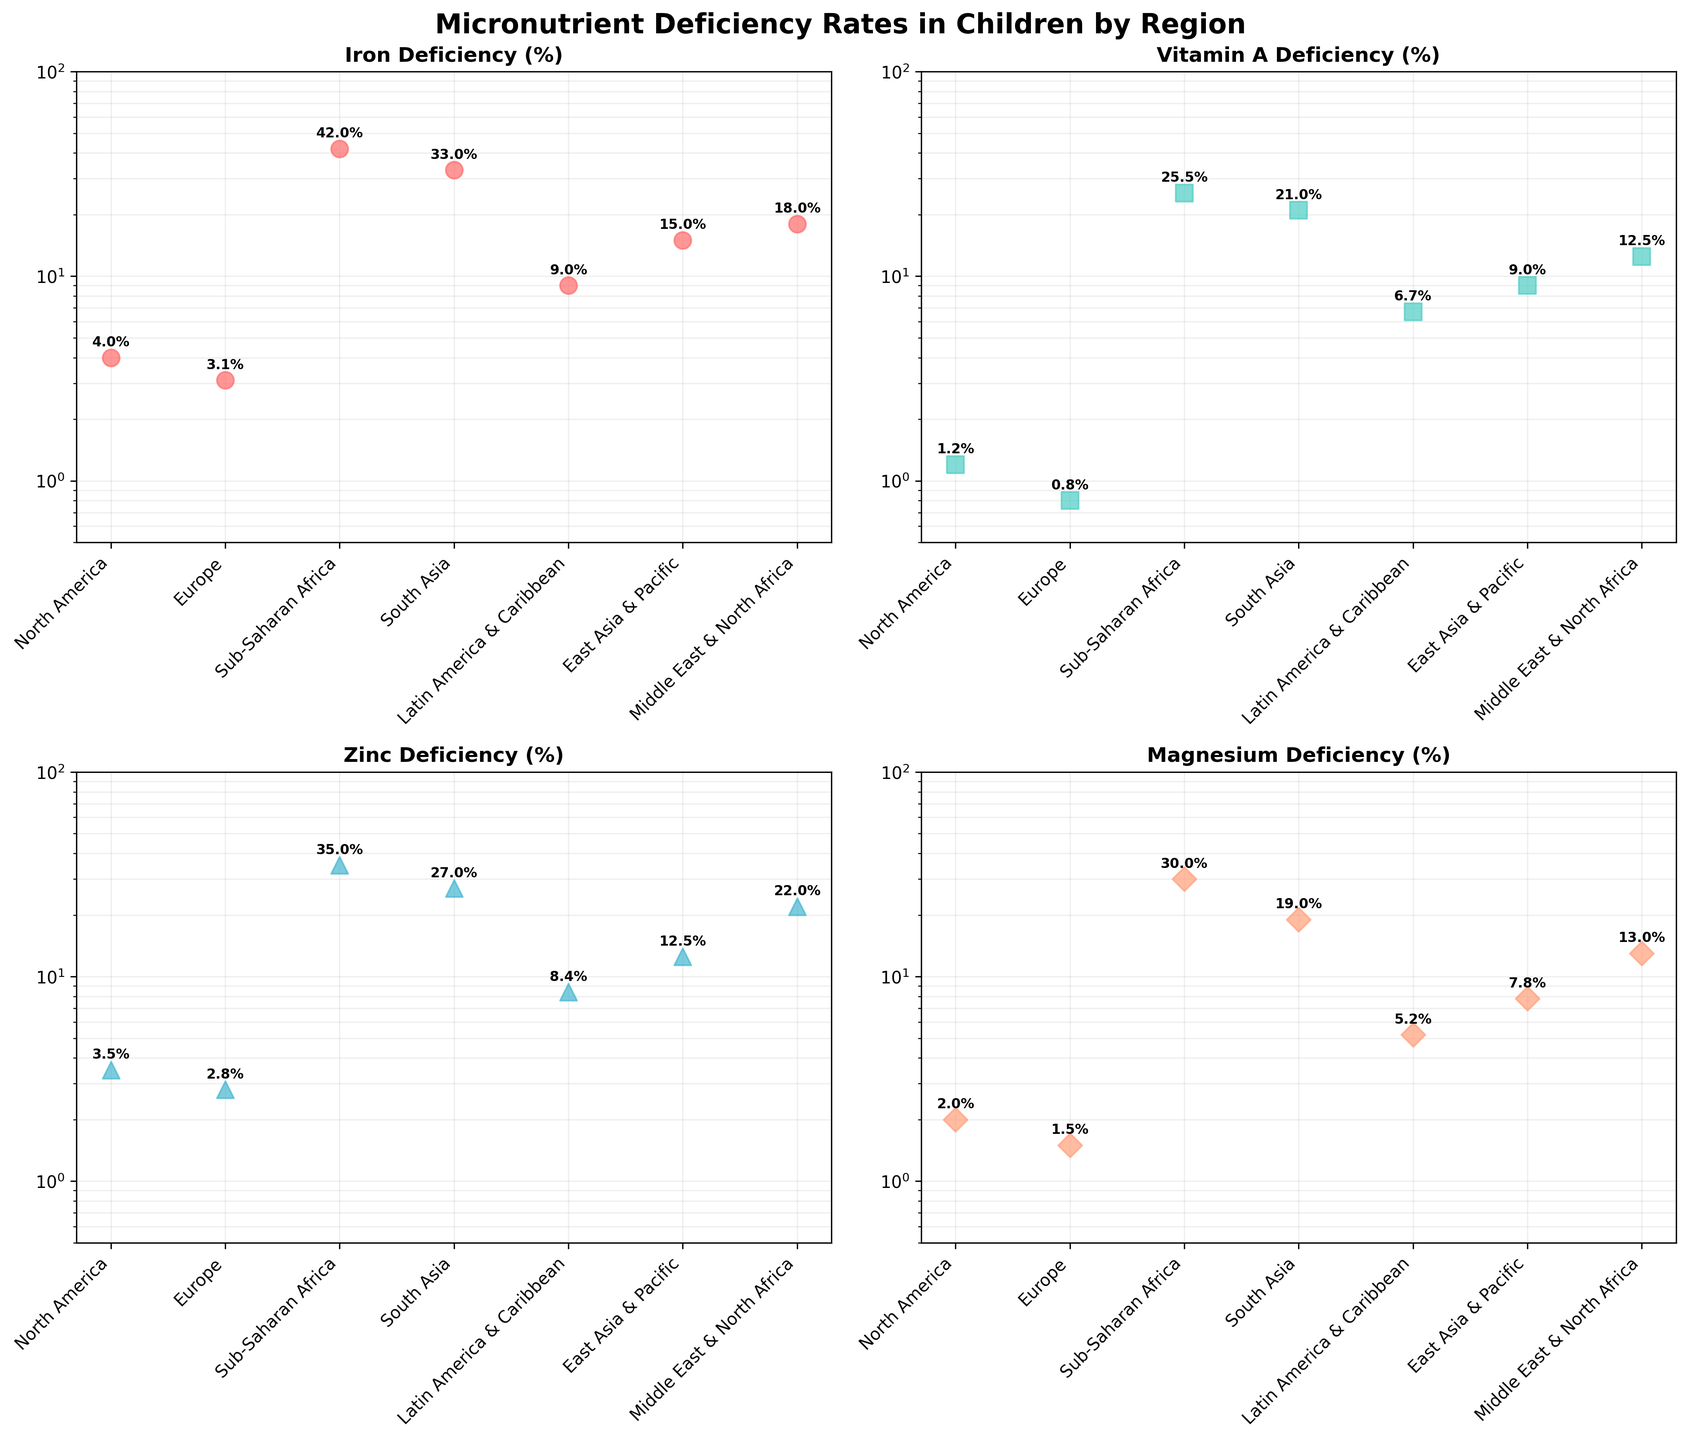What is the title of the figure? The title is found at the top of the figure and summarizes what the figure is about. The title given is "Micronutrient Deficiency Rates in Children by Region".
Answer: Micronutrient Deficiency Rates in Children by Region How many subplots are there in the figure? By looking at the figure layout, there are four different scatter plots, each representing a different micronutrient deficiency.
Answer: 4 Which region has the highest iron deficiency rate? By looking at the scatter plot for "Iron Deficiency (%)", the highest data point is in the "Sub-Saharan Africa" region.
Answer: Sub-Saharan Africa What is the percentage of Vitamin A deficiency in South Asia? By looking at the scatter plot for "Vitamin A Deficiency (%)", the data point for "South Asia" is annotated with "21%".
Answer: 21% Which region has the lowest zinc deficiency rate and what is the rate? By looking at the scatter plot for "Zinc Deficiency (%)", the lowest data point, annotated with "2.8%", is in the "Europe" region.
Answer: Europe, 2.8% What's the range of magnesium deficiency rates (the difference between the highest and lowest values)? By observing the scatter plot for "Magnesium Deficiency (%)", the highest value is 30 (Sub-Saharan Africa) and the lowest value is 1.5 (Europe). The range is calculated as 30 - 1.5.
Answer: 28.5 Compare the iron deficiency rates in Latin America & Caribbean to East Asia & Pacific. Which region has a higher rate? By inspecting the "Iron Deficiency (%)" subplot, Latin America & Caribbean has a rate of 9%, and East Asia & Pacific has a rate of 15%. Therefore, East Asia & Pacific has a higher rate.
Answer: East Asia & Pacific What observations can be made about the log scale used for all the subplots? The y-axis in all plots is on a log scale, which allows better visualization of both small and large deficiency rates. The log scale compresses the higher values and expands the lower values for clarity.
Answer: It provides a clearer view of different rates Which two regions have similar Vitamin A deficiency rates? By checking the scatter plot for "Vitamin A Deficiency (%)", "East Asia & Pacific" (9%) and "Latin America & Caribbean" (6.7%) have relatively close rates comparatively to other regions.
Answer: East Asia & Pacific and Latin America & Caribbean What is the average zinc deficiency rate across all regions? The zinc deficiency rates are: 3.5, 2.8, 35, 27, 8.4, 12.5, 22. Adding these rates gives 111.2. Dividing by 7 (the number of regions) results in an average of 15.8857.
Answer: 15.9 